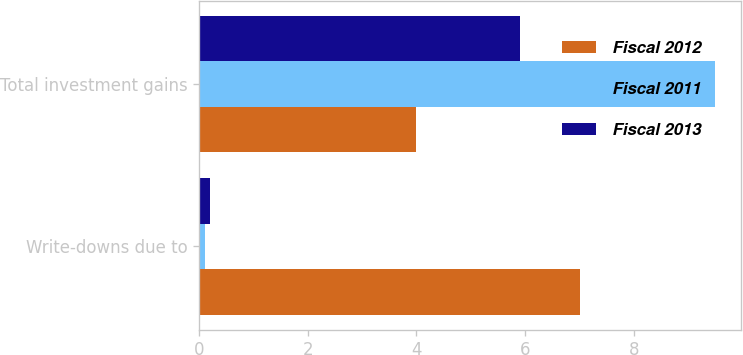Convert chart. <chart><loc_0><loc_0><loc_500><loc_500><stacked_bar_chart><ecel><fcel>Write-downs due to<fcel>Total investment gains<nl><fcel>Fiscal 2012<fcel>7<fcel>4<nl><fcel>Fiscal 2011<fcel>0.1<fcel>9.5<nl><fcel>Fiscal 2013<fcel>0.2<fcel>5.9<nl></chart> 